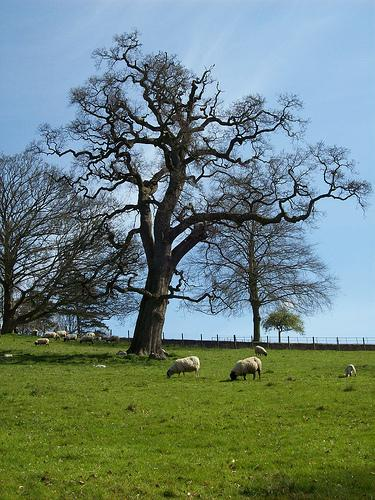Analyze the interaction between the main objects in the image, such as the sheep, tree, and gate. The main objects in the image – the sheep, tree, and gate – interact in a harmonious manner as the tree provides shade to the sheep grazing nearby, and the gate helps to keep the sheep confined in the grassy field. Considering the image's context, suggest a possible reason for the presence of the wired gate. The wired gate is likely present to prevent the sheep from wandering away from the field and to ensure their safety within the designated grazing area. What type of fence is being used to keep the sheep confined, and where is it located in the image? A wired gate is being used to keep the sheep confined, and it is located at coordinates (171, 331) in the image. Identify the image's central theme by mentioning its main elements. The image's central theme revolves around a green, grassy field with sheep grazing, a large tree, and a clear blue sky. Provide an emotional analysis of the image by discussing its main elements and general atmosphere. The image evokes a calm and peaceful atmosphere, with sheep grazing on a green, grassy field, large trees, and a clear blue sky in the background. What are the primary colors involved in this image's composition? Green and blue are the primary colors, with green dominant in the grass and trees, and blue in the sky. Count the total number of sheep present in the image, and describe their primary activities. There are a total of 8 sheep in the image; their primary activities include grazing on grass, lying down, and being close to the gate or tree. Estimate the quality of the image in terms of colors, composition, and clarity of the objects. The image is of high quality, with vivid and natural colors such as green and blue, a balanced composition featuring a field, trees, and sky, and clear details of the sheep and other objects. Can you name the animal featured in this image, and describe its appearance? The animal featured in the image is a sheep, some of which are white with black faces, and they are grazing on grass or lying down in the field. Describe the position of the main focal points in this image using their coordinates. The focal points include a huge tree at coordinates (50, 35), sheep grazing at coordinates (135, 342), and a wired gate at coordinates (171, 331). 